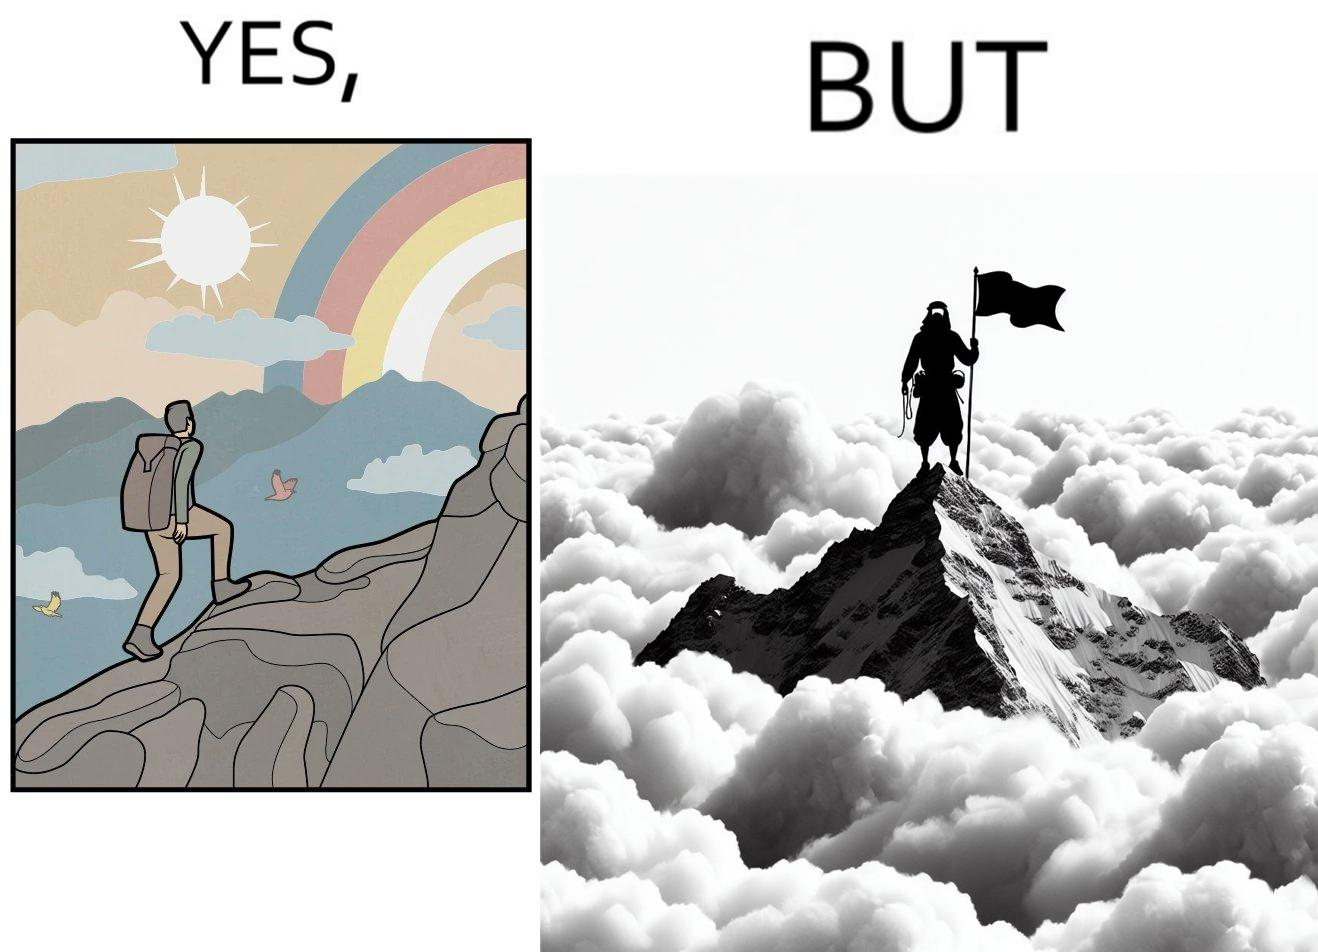Describe what you see in this image. The image is ironic, because the mountaineer climbs up the mountain to view the world from the peak but due to so much cloud, at the top, nothing is visible whereas he was able to witness some awesome views while climbing up the mountain 